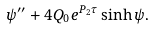<formula> <loc_0><loc_0><loc_500><loc_500>\psi ^ { \prime \prime } + 4 Q _ { 0 } e ^ { P _ { 2 } \tau } \sinh \psi .</formula> 